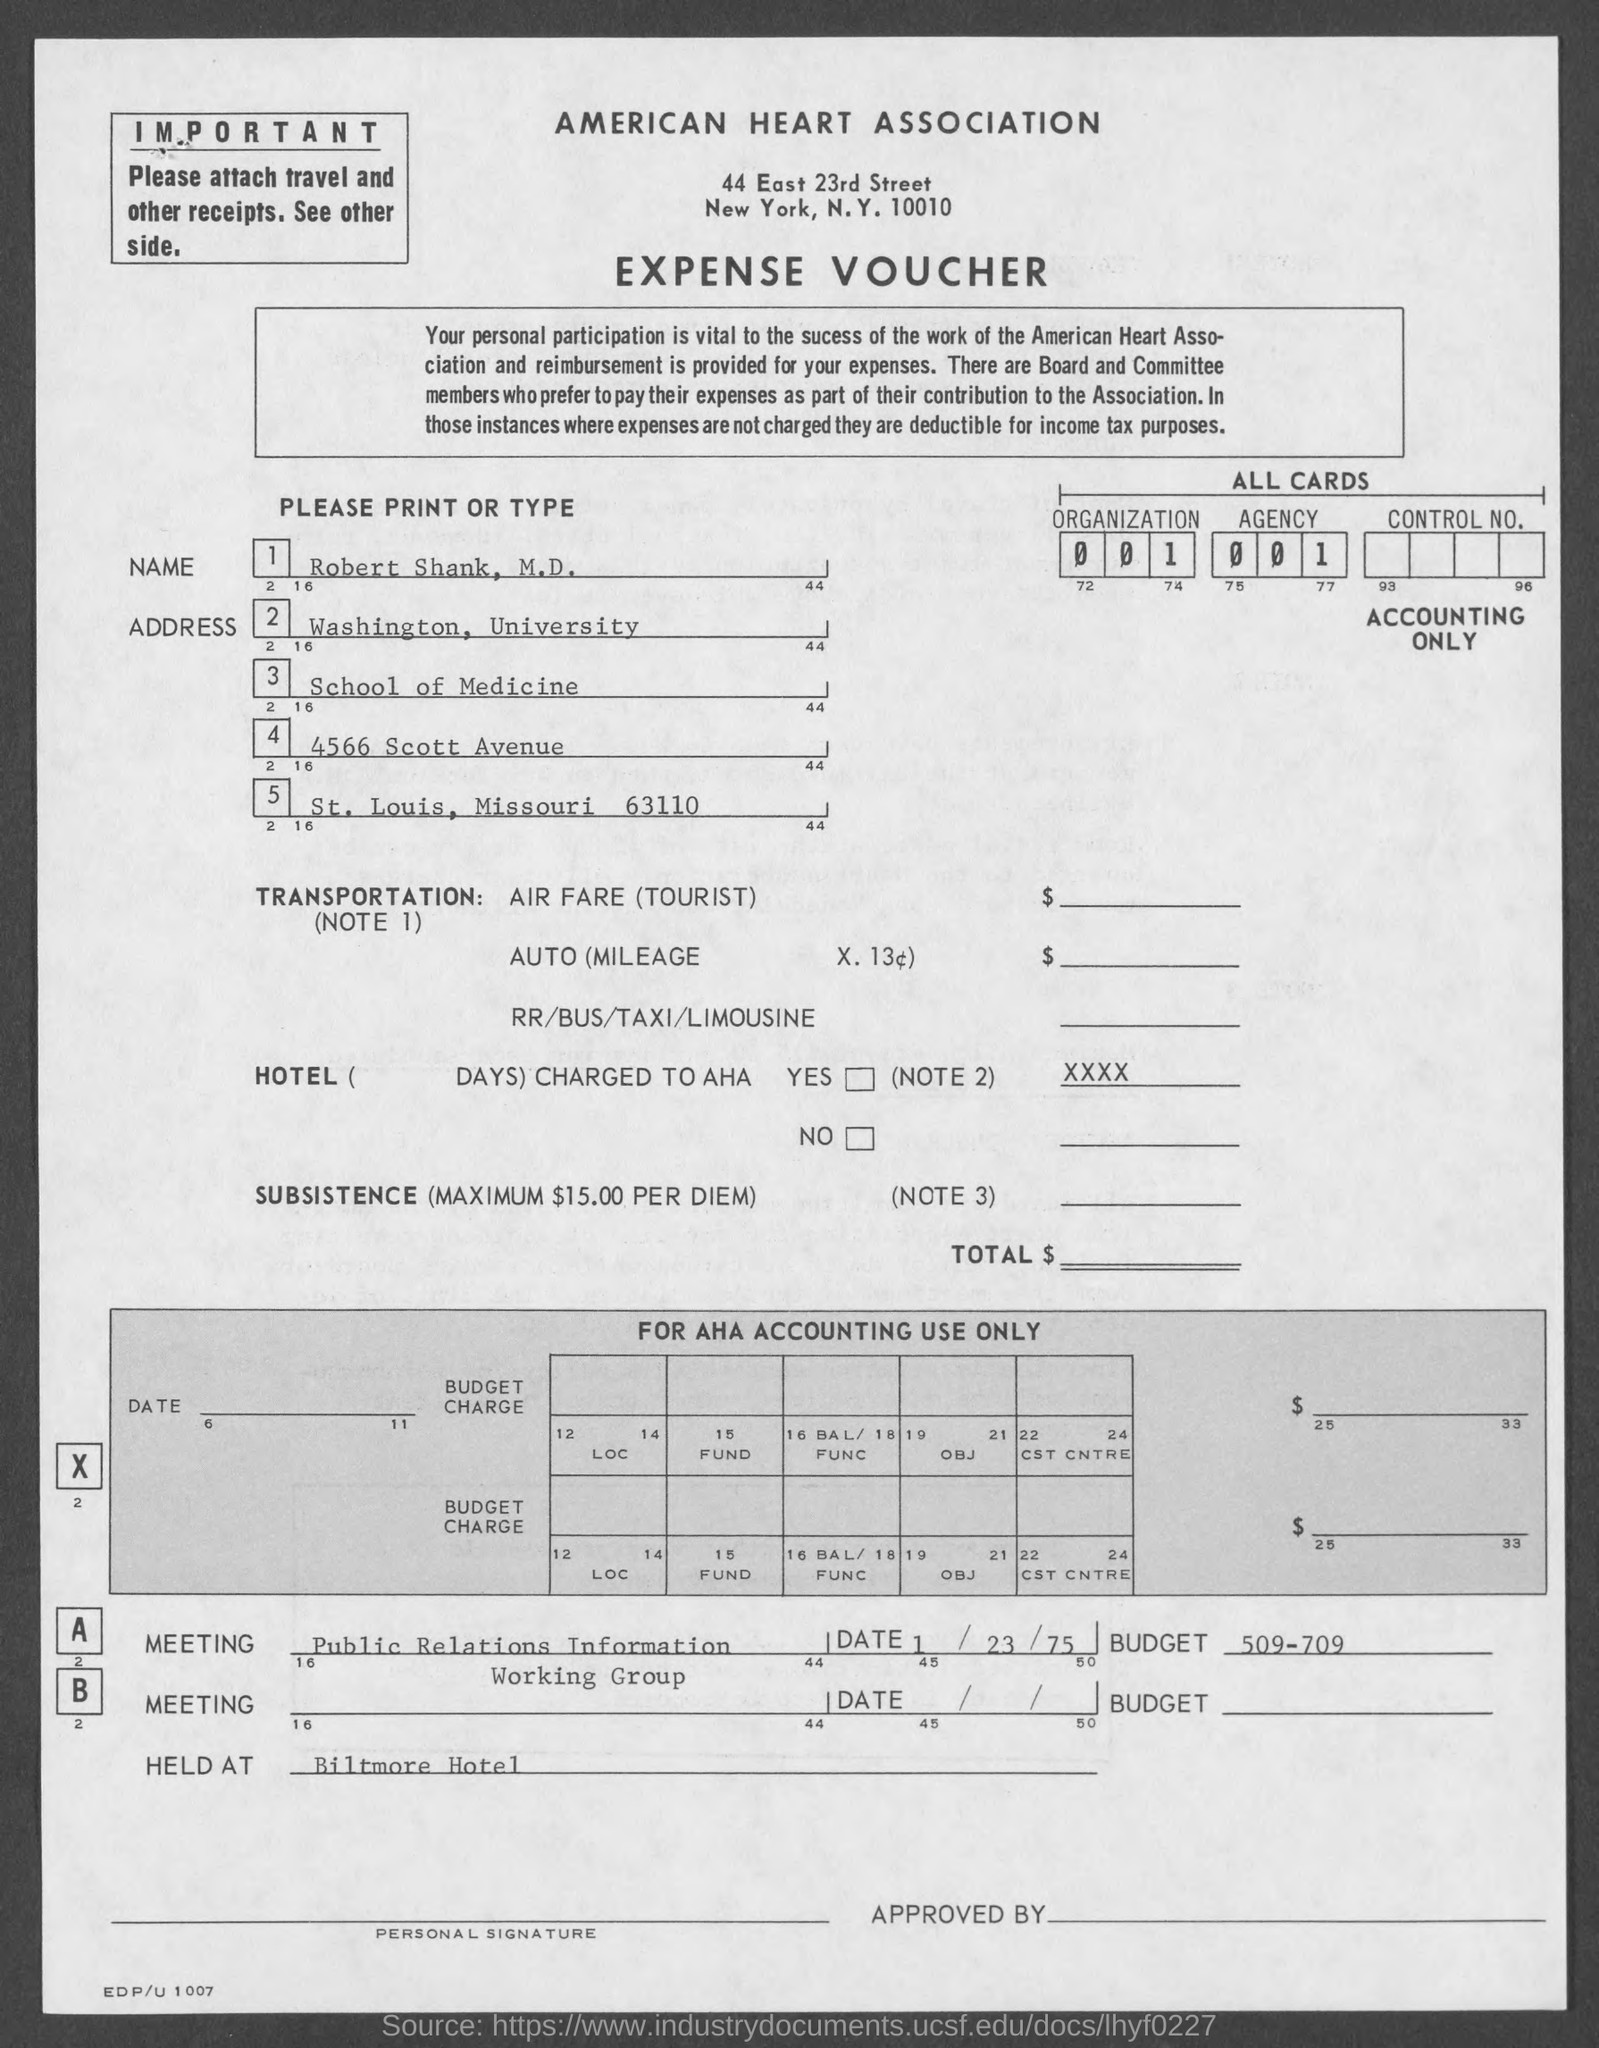Point out several critical features in this image. The voucher is associated with the American Heart Association. The budget of meeting A was 509-709. This is an expense voucher. Robert Shank is located in the state of Missouri. The meeting was held at the Biltmore hotel. 